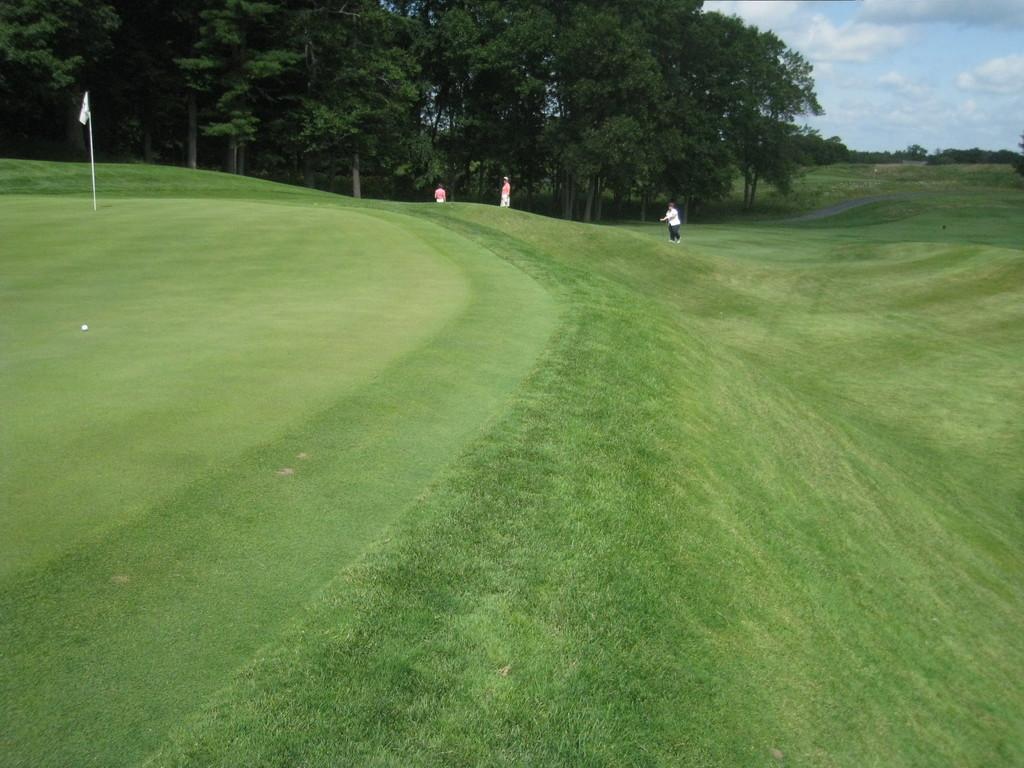How would you summarize this image in a sentence or two? In the picture I can see the natural scenery of green grass and trees. I can see three persons. There is a flagpole on the top left side and I can see the golf ball on the grass on the left side. There are clouds in the sky. 